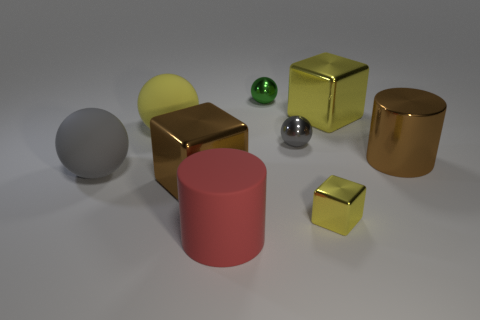What number of spheres are green metallic objects or gray matte things?
Your response must be concise. 2. What number of objects are yellow spheres or yellow things that are to the left of the red cylinder?
Your answer should be very brief. 1. Are there any tiny yellow metal cylinders?
Your answer should be very brief. No. How many matte things are the same color as the small cube?
Provide a succinct answer. 1. There is a big ball that is the same color as the small shiny cube; what is its material?
Offer a terse response. Rubber. There is a brown object that is left of the yellow thing that is in front of the large gray ball; what is its size?
Provide a succinct answer. Large. Are there any small gray objects made of the same material as the brown block?
Your answer should be very brief. Yes. There is a gray ball that is the same size as the red matte thing; what is its material?
Offer a very short reply. Rubber. Do the ball that is on the right side of the tiny green shiny ball and the large cylinder that is behind the rubber cylinder have the same color?
Make the answer very short. No. There is a large yellow matte ball that is behind the small yellow metal object; is there a yellow thing on the right side of it?
Ensure brevity in your answer.  Yes. 